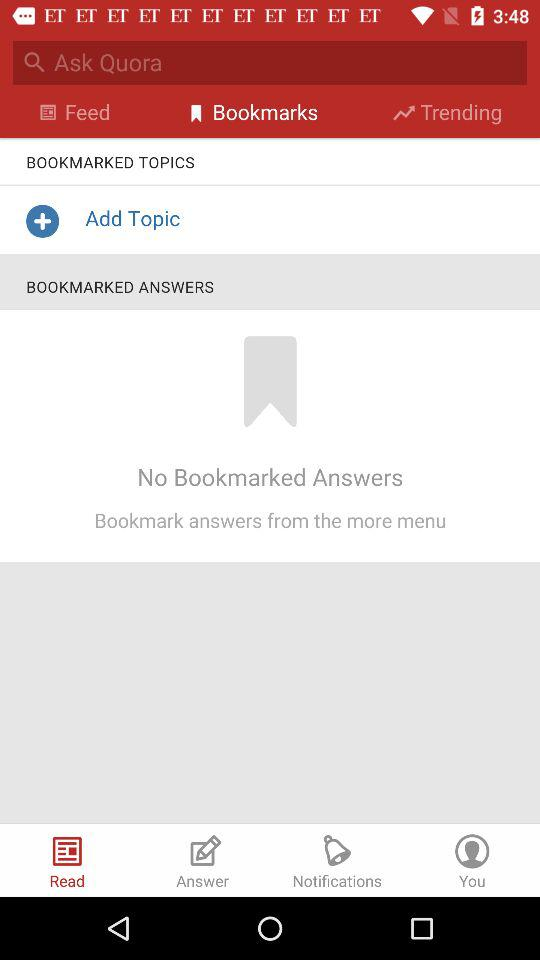How many bookmarks are there?
Answer the question using a single word or phrase. 0 